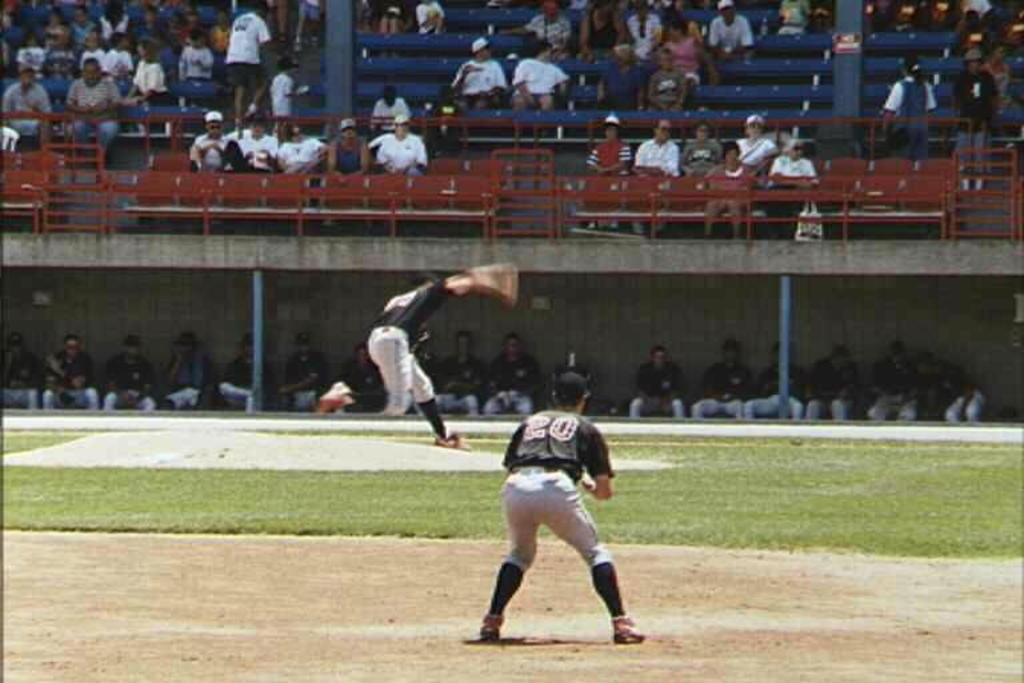Provide a one-sentence caption for the provided image. A man in a 20 jersey prepares on a baseball field. 